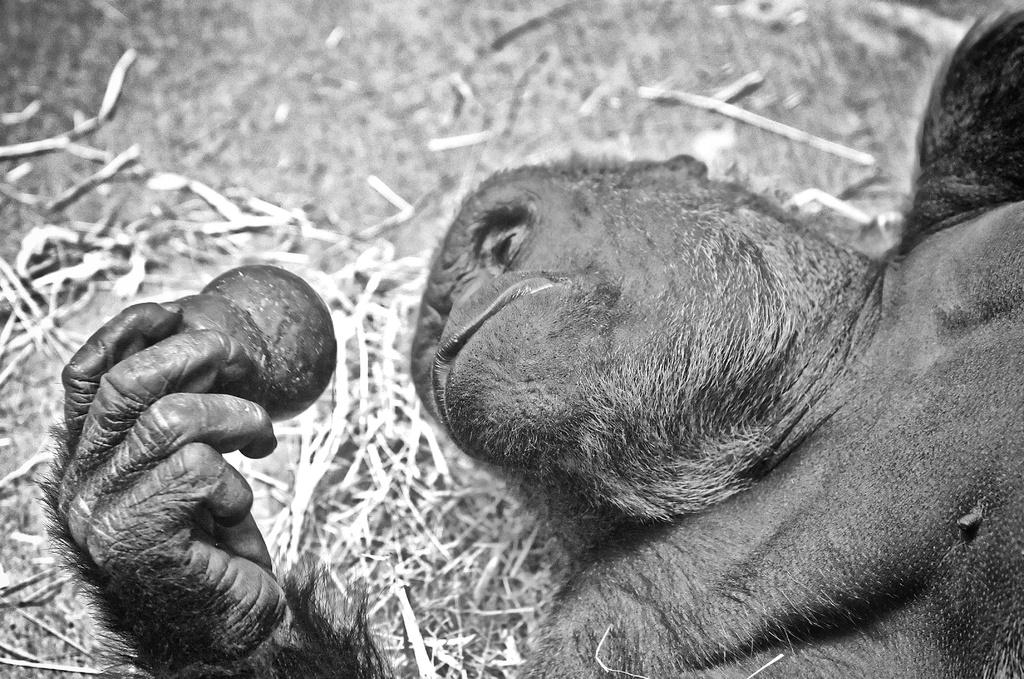What is the color scheme of the picture? The picture is black and white. What type of subject can be seen in the image? There is an animal in the picture. Where is the cup placed in the image? There is no cup present in the image. What type of bomb is depicted in the image? There is no bomb present in the image. 